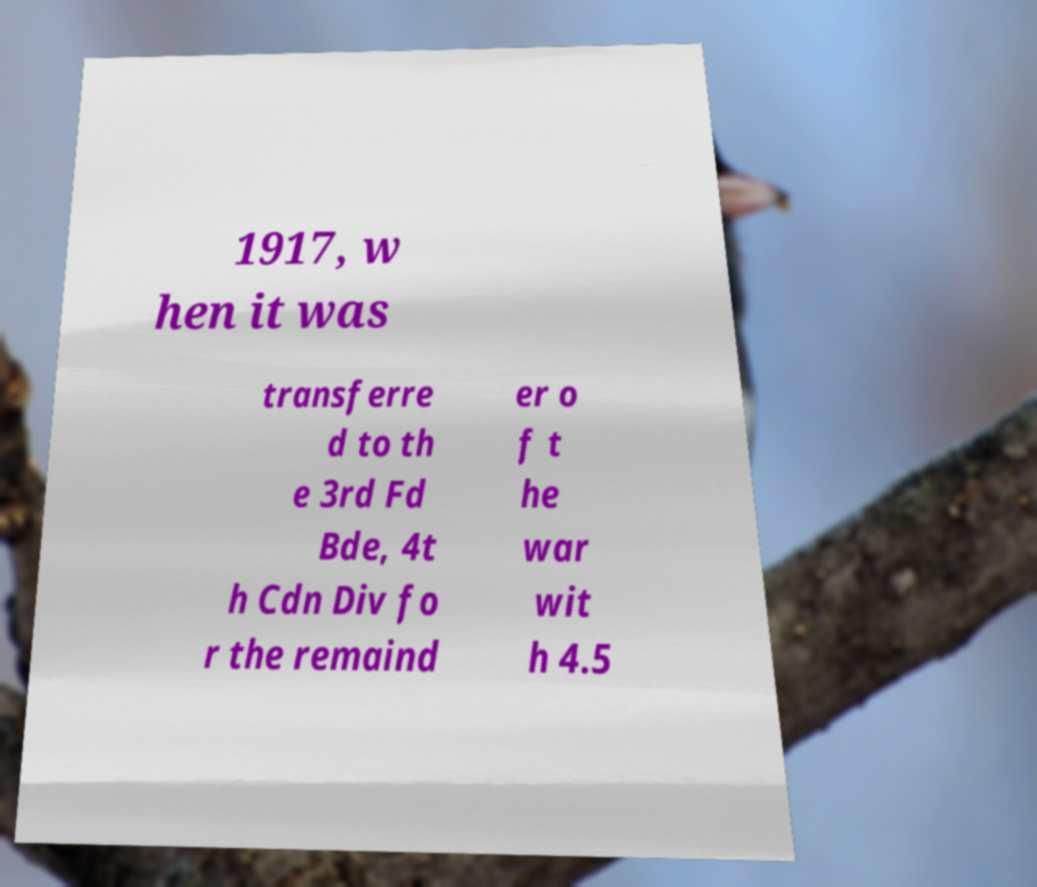There's text embedded in this image that I need extracted. Can you transcribe it verbatim? 1917, w hen it was transferre d to th e 3rd Fd Bde, 4t h Cdn Div fo r the remaind er o f t he war wit h 4.5 